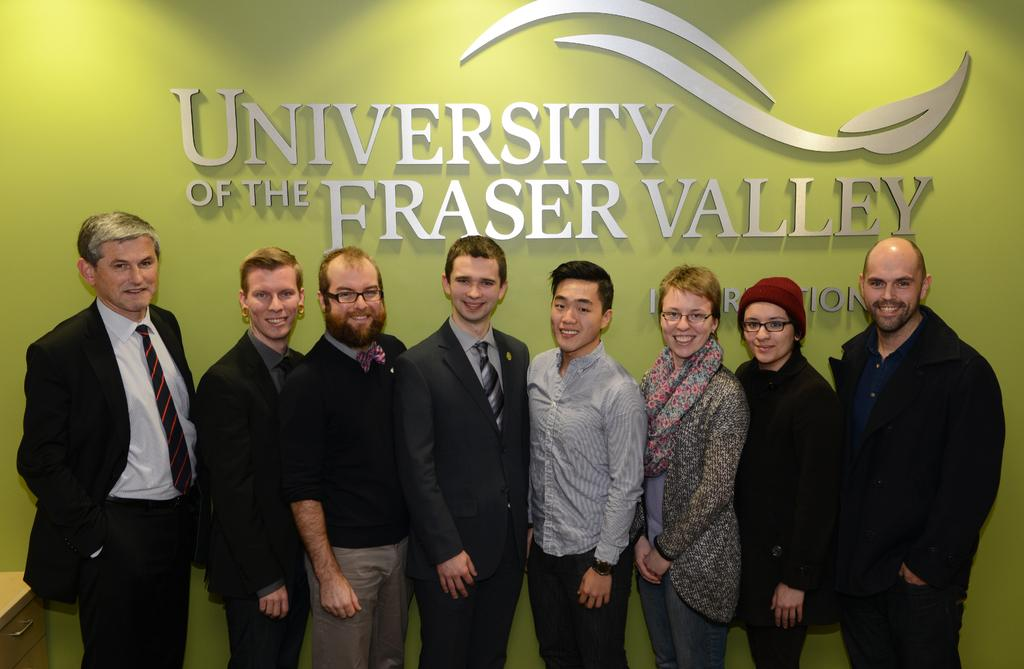How many people are in the image? A: There is a group of people standing in the image. What object can be seen on the bottom left of the image? There is a cupboard on the bottom left of the image. What is present on the wall in the background of the image? There is a wall with some text on it in the background of the image. Can you tell me the name of the girl standing next to the grandfather in the image? There is no girl or grandfather present in the image. 